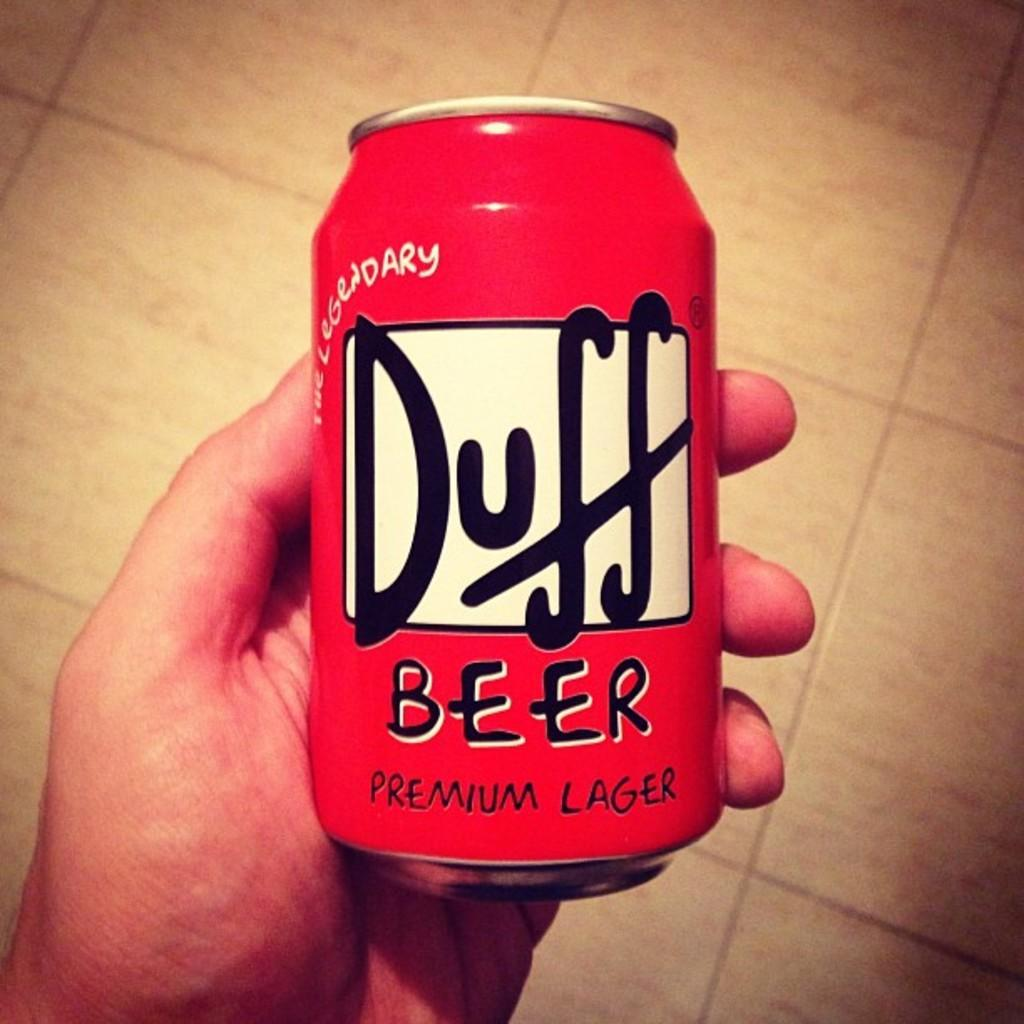<image>
Describe the image concisely. A person is holding a red can of beer that says Duff Beer Premium Lager. 